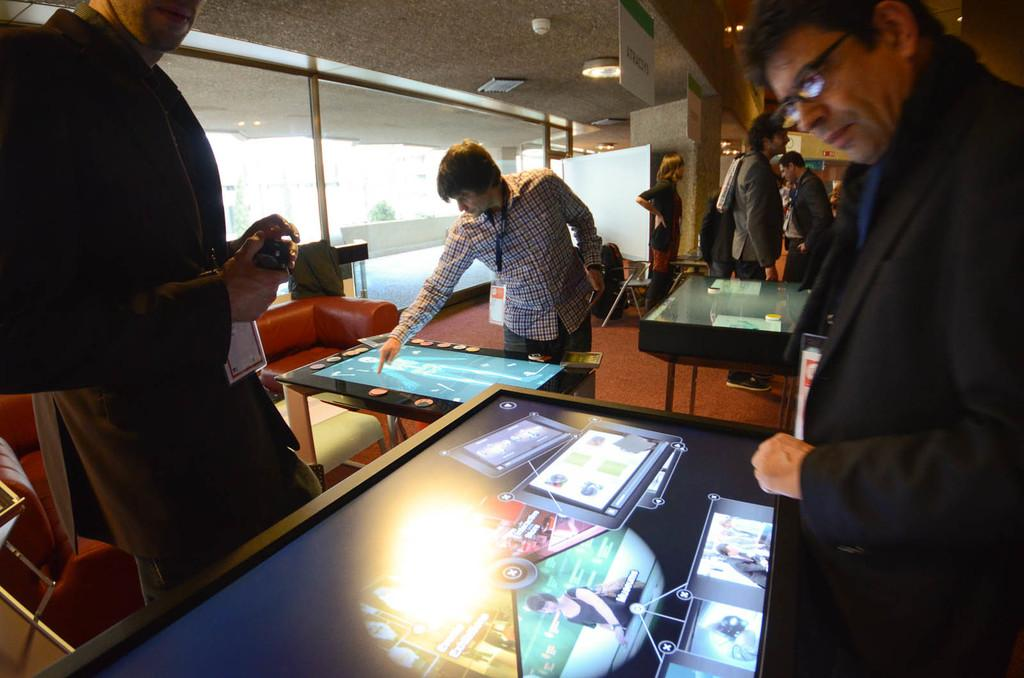What type of furniture is present in the image? There are tables in the image. What are the people in the image doing? People are standing around the tables. What can be seen in the background of the image? There is a sofa, chairs, and a glass wall in the background of the image. What is visible at the top of the image? The ceiling is visible at the top of the image. What might be used for illumination in the image? Lights are present in the image. How much wealth is displayed on the tables in the image? There is no indication of wealth displayed on the tables in the image. Can you tell me how many people are driving in the image? There is no driving activity depicted in the image. 